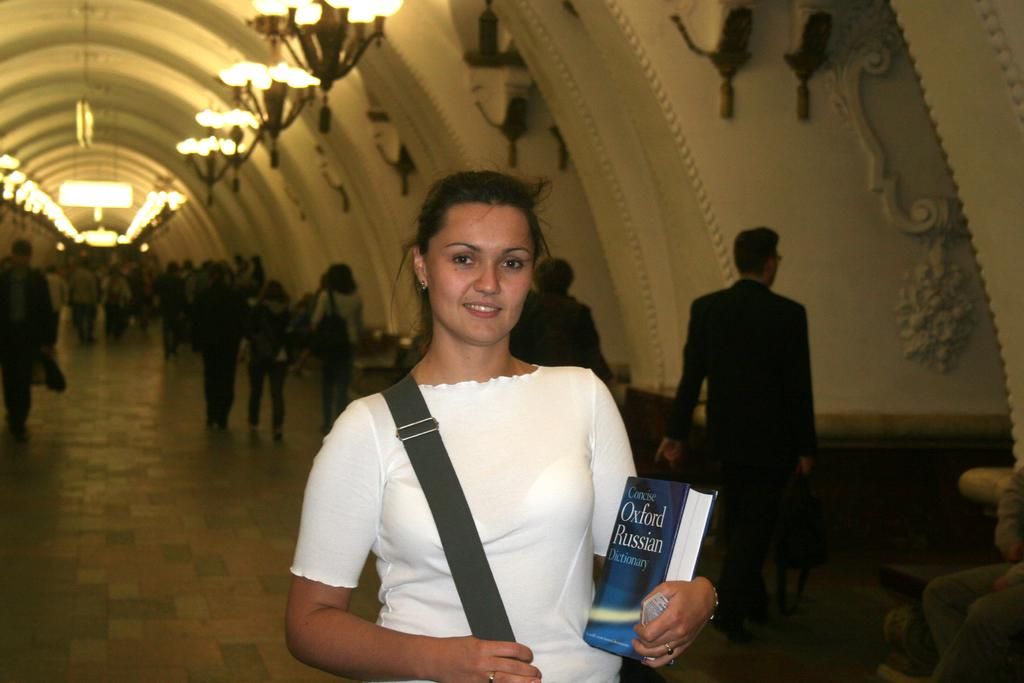Who is the main subject in the image? There is a woman in the image. What is the woman holding in the image? The woman is holding a book. What is the woman's facial expression in the image? The woman is smiling. What type of surface is visible in the image? There is a floor in the image. What can be seen illuminating the scene in the image? There are lights visible in the image. What can be seen in the background of the image? There is a group of people and a wall in the background of the image. How does the woman support the cannon in the image? There is no cannon present in the image, so the woman cannot support it. 